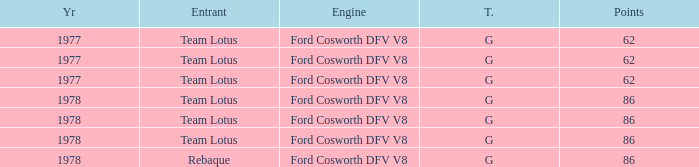What is the Focus that has a Year bigger than 1977? 86, 86, 86, 86. 